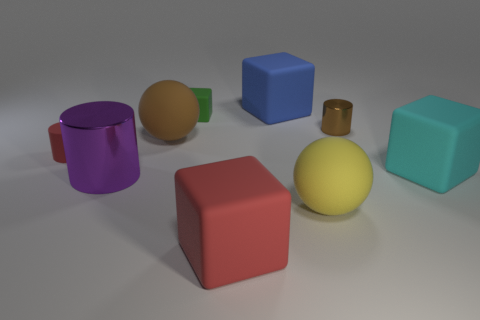Subtract 1 cubes. How many cubes are left? 3 Subtract all gray cubes. Subtract all green cylinders. How many cubes are left? 4 Add 1 cyan rubber balls. How many objects exist? 10 Subtract all balls. How many objects are left? 7 Add 3 blue cubes. How many blue cubes are left? 4 Add 7 purple shiny cylinders. How many purple shiny cylinders exist? 8 Subtract 0 gray spheres. How many objects are left? 9 Subtract all cyan cubes. Subtract all cyan matte things. How many objects are left? 7 